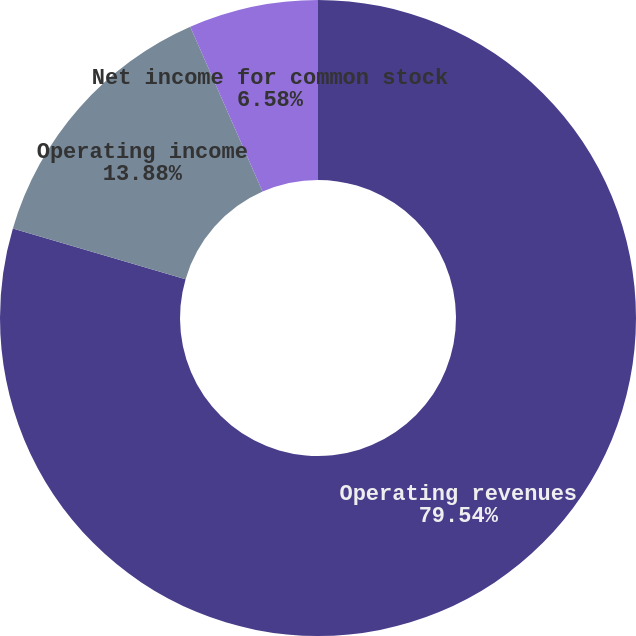Convert chart. <chart><loc_0><loc_0><loc_500><loc_500><pie_chart><fcel>Operating revenues<fcel>Operating income<fcel>Net income for common stock<nl><fcel>79.55%<fcel>13.88%<fcel>6.58%<nl></chart> 